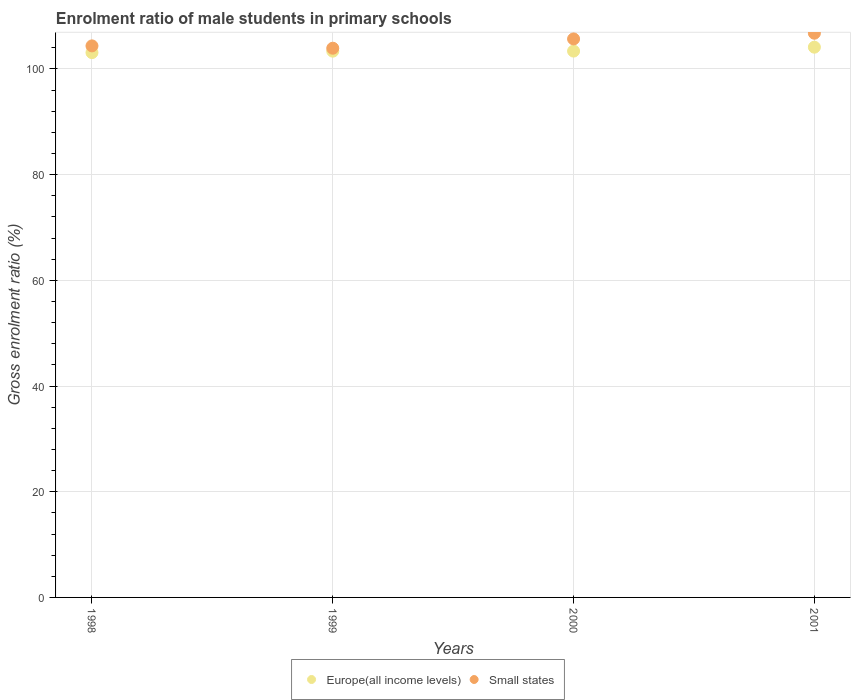Is the number of dotlines equal to the number of legend labels?
Your answer should be compact. Yes. What is the enrolment ratio of male students in primary schools in Europe(all income levels) in 1999?
Give a very brief answer. 103.35. Across all years, what is the maximum enrolment ratio of male students in primary schools in Europe(all income levels)?
Your response must be concise. 104.1. Across all years, what is the minimum enrolment ratio of male students in primary schools in Small states?
Offer a very short reply. 103.91. In which year was the enrolment ratio of male students in primary schools in Europe(all income levels) minimum?
Offer a very short reply. 1998. What is the total enrolment ratio of male students in primary schools in Europe(all income levels) in the graph?
Give a very brief answer. 413.89. What is the difference between the enrolment ratio of male students in primary schools in Small states in 2000 and that in 2001?
Offer a very short reply. -1.08. What is the difference between the enrolment ratio of male students in primary schools in Europe(all income levels) in 1999 and the enrolment ratio of male students in primary schools in Small states in 2000?
Your answer should be compact. -2.32. What is the average enrolment ratio of male students in primary schools in Europe(all income levels) per year?
Offer a terse response. 103.47. In the year 2000, what is the difference between the enrolment ratio of male students in primary schools in Small states and enrolment ratio of male students in primary schools in Europe(all income levels)?
Your answer should be compact. 2.3. In how many years, is the enrolment ratio of male students in primary schools in Small states greater than 100 %?
Your answer should be compact. 4. What is the ratio of the enrolment ratio of male students in primary schools in Small states in 1998 to that in 2001?
Your response must be concise. 0.98. Is the enrolment ratio of male students in primary schools in Europe(all income levels) in 1999 less than that in 2000?
Keep it short and to the point. Yes. Is the difference between the enrolment ratio of male students in primary schools in Small states in 2000 and 2001 greater than the difference between the enrolment ratio of male students in primary schools in Europe(all income levels) in 2000 and 2001?
Provide a succinct answer. No. What is the difference between the highest and the second highest enrolment ratio of male students in primary schools in Small states?
Your response must be concise. 1.08. What is the difference between the highest and the lowest enrolment ratio of male students in primary schools in Small states?
Offer a terse response. 2.84. Is the enrolment ratio of male students in primary schools in Europe(all income levels) strictly less than the enrolment ratio of male students in primary schools in Small states over the years?
Make the answer very short. Yes. How many years are there in the graph?
Ensure brevity in your answer.  4. What is the difference between two consecutive major ticks on the Y-axis?
Provide a succinct answer. 20. Are the values on the major ticks of Y-axis written in scientific E-notation?
Provide a short and direct response. No. Does the graph contain grids?
Make the answer very short. Yes. How many legend labels are there?
Make the answer very short. 2. How are the legend labels stacked?
Your answer should be very brief. Horizontal. What is the title of the graph?
Provide a succinct answer. Enrolment ratio of male students in primary schools. What is the label or title of the Y-axis?
Ensure brevity in your answer.  Gross enrolment ratio (%). What is the Gross enrolment ratio (%) in Europe(all income levels) in 1998?
Provide a short and direct response. 103.07. What is the Gross enrolment ratio (%) of Small states in 1998?
Provide a succinct answer. 104.35. What is the Gross enrolment ratio (%) of Europe(all income levels) in 1999?
Your answer should be very brief. 103.35. What is the Gross enrolment ratio (%) in Small states in 1999?
Your answer should be compact. 103.91. What is the Gross enrolment ratio (%) in Europe(all income levels) in 2000?
Offer a very short reply. 103.37. What is the Gross enrolment ratio (%) in Small states in 2000?
Ensure brevity in your answer.  105.67. What is the Gross enrolment ratio (%) of Europe(all income levels) in 2001?
Make the answer very short. 104.1. What is the Gross enrolment ratio (%) of Small states in 2001?
Keep it short and to the point. 106.75. Across all years, what is the maximum Gross enrolment ratio (%) in Europe(all income levels)?
Keep it short and to the point. 104.1. Across all years, what is the maximum Gross enrolment ratio (%) of Small states?
Give a very brief answer. 106.75. Across all years, what is the minimum Gross enrolment ratio (%) in Europe(all income levels)?
Your answer should be compact. 103.07. Across all years, what is the minimum Gross enrolment ratio (%) in Small states?
Your answer should be compact. 103.91. What is the total Gross enrolment ratio (%) in Europe(all income levels) in the graph?
Offer a very short reply. 413.89. What is the total Gross enrolment ratio (%) of Small states in the graph?
Ensure brevity in your answer.  420.67. What is the difference between the Gross enrolment ratio (%) of Europe(all income levels) in 1998 and that in 1999?
Offer a terse response. -0.28. What is the difference between the Gross enrolment ratio (%) in Small states in 1998 and that in 1999?
Make the answer very short. 0.44. What is the difference between the Gross enrolment ratio (%) in Europe(all income levels) in 1998 and that in 2000?
Make the answer very short. -0.29. What is the difference between the Gross enrolment ratio (%) in Small states in 1998 and that in 2000?
Your answer should be compact. -1.32. What is the difference between the Gross enrolment ratio (%) in Europe(all income levels) in 1998 and that in 2001?
Provide a succinct answer. -1.03. What is the difference between the Gross enrolment ratio (%) in Small states in 1998 and that in 2001?
Provide a short and direct response. -2.4. What is the difference between the Gross enrolment ratio (%) in Europe(all income levels) in 1999 and that in 2000?
Give a very brief answer. -0.02. What is the difference between the Gross enrolment ratio (%) of Small states in 1999 and that in 2000?
Provide a succinct answer. -1.76. What is the difference between the Gross enrolment ratio (%) of Europe(all income levels) in 1999 and that in 2001?
Your answer should be very brief. -0.75. What is the difference between the Gross enrolment ratio (%) in Small states in 1999 and that in 2001?
Give a very brief answer. -2.84. What is the difference between the Gross enrolment ratio (%) of Europe(all income levels) in 2000 and that in 2001?
Your answer should be compact. -0.74. What is the difference between the Gross enrolment ratio (%) in Small states in 2000 and that in 2001?
Offer a terse response. -1.08. What is the difference between the Gross enrolment ratio (%) of Europe(all income levels) in 1998 and the Gross enrolment ratio (%) of Small states in 1999?
Provide a short and direct response. -0.84. What is the difference between the Gross enrolment ratio (%) in Europe(all income levels) in 1998 and the Gross enrolment ratio (%) in Small states in 2000?
Your response must be concise. -2.59. What is the difference between the Gross enrolment ratio (%) in Europe(all income levels) in 1998 and the Gross enrolment ratio (%) in Small states in 2001?
Keep it short and to the point. -3.67. What is the difference between the Gross enrolment ratio (%) of Europe(all income levels) in 1999 and the Gross enrolment ratio (%) of Small states in 2000?
Make the answer very short. -2.32. What is the difference between the Gross enrolment ratio (%) of Europe(all income levels) in 1999 and the Gross enrolment ratio (%) of Small states in 2001?
Your answer should be compact. -3.4. What is the difference between the Gross enrolment ratio (%) of Europe(all income levels) in 2000 and the Gross enrolment ratio (%) of Small states in 2001?
Make the answer very short. -3.38. What is the average Gross enrolment ratio (%) of Europe(all income levels) per year?
Ensure brevity in your answer.  103.47. What is the average Gross enrolment ratio (%) in Small states per year?
Offer a terse response. 105.17. In the year 1998, what is the difference between the Gross enrolment ratio (%) in Europe(all income levels) and Gross enrolment ratio (%) in Small states?
Your response must be concise. -1.28. In the year 1999, what is the difference between the Gross enrolment ratio (%) of Europe(all income levels) and Gross enrolment ratio (%) of Small states?
Make the answer very short. -0.56. In the year 2000, what is the difference between the Gross enrolment ratio (%) in Europe(all income levels) and Gross enrolment ratio (%) in Small states?
Provide a short and direct response. -2.3. In the year 2001, what is the difference between the Gross enrolment ratio (%) in Europe(all income levels) and Gross enrolment ratio (%) in Small states?
Your answer should be compact. -2.64. What is the ratio of the Gross enrolment ratio (%) in Europe(all income levels) in 1998 to that in 1999?
Offer a terse response. 1. What is the ratio of the Gross enrolment ratio (%) in Small states in 1998 to that in 2000?
Your response must be concise. 0.99. What is the ratio of the Gross enrolment ratio (%) of Small states in 1998 to that in 2001?
Provide a succinct answer. 0.98. What is the ratio of the Gross enrolment ratio (%) in Small states in 1999 to that in 2000?
Offer a very short reply. 0.98. What is the ratio of the Gross enrolment ratio (%) of Europe(all income levels) in 1999 to that in 2001?
Give a very brief answer. 0.99. What is the ratio of the Gross enrolment ratio (%) of Small states in 1999 to that in 2001?
Offer a terse response. 0.97. What is the ratio of the Gross enrolment ratio (%) of Europe(all income levels) in 2000 to that in 2001?
Offer a terse response. 0.99. What is the ratio of the Gross enrolment ratio (%) in Small states in 2000 to that in 2001?
Your answer should be compact. 0.99. What is the difference between the highest and the second highest Gross enrolment ratio (%) in Europe(all income levels)?
Ensure brevity in your answer.  0.74. What is the difference between the highest and the second highest Gross enrolment ratio (%) in Small states?
Make the answer very short. 1.08. What is the difference between the highest and the lowest Gross enrolment ratio (%) in Europe(all income levels)?
Make the answer very short. 1.03. What is the difference between the highest and the lowest Gross enrolment ratio (%) of Small states?
Ensure brevity in your answer.  2.84. 